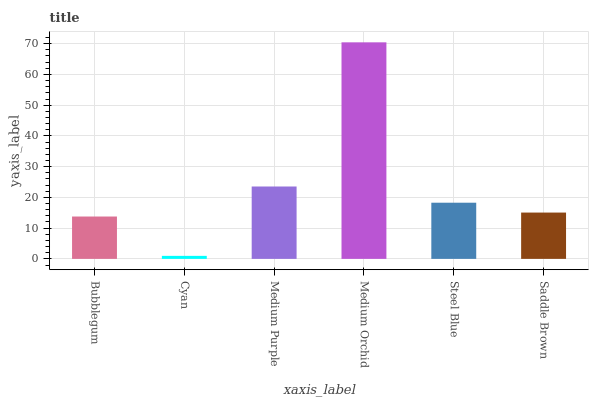Is Cyan the minimum?
Answer yes or no. Yes. Is Medium Orchid the maximum?
Answer yes or no. Yes. Is Medium Purple the minimum?
Answer yes or no. No. Is Medium Purple the maximum?
Answer yes or no. No. Is Medium Purple greater than Cyan?
Answer yes or no. Yes. Is Cyan less than Medium Purple?
Answer yes or no. Yes. Is Cyan greater than Medium Purple?
Answer yes or no. No. Is Medium Purple less than Cyan?
Answer yes or no. No. Is Steel Blue the high median?
Answer yes or no. Yes. Is Saddle Brown the low median?
Answer yes or no. Yes. Is Cyan the high median?
Answer yes or no. No. Is Medium Purple the low median?
Answer yes or no. No. 